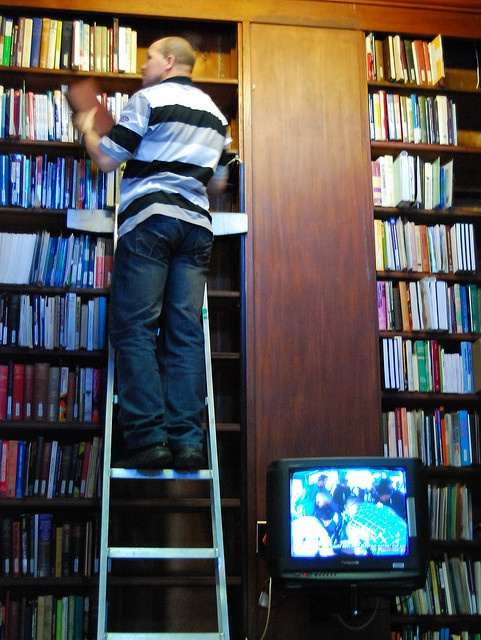Describe the objects in this image and their specific colors. I can see people in maroon, black, navy, white, and blue tones, tv in maroon, black, white, cyan, and navy tones, book in maroon, black, brown, and purple tones, book in maroon, black, and gray tones, and book in maroon, ivory, darkgray, beige, and lightblue tones in this image. 